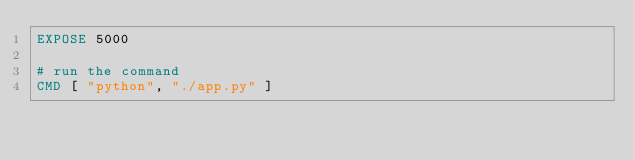<code> <loc_0><loc_0><loc_500><loc_500><_Dockerfile_>EXPOSE 5000

# run the command
CMD [ "python", "./app.py" ]</code> 